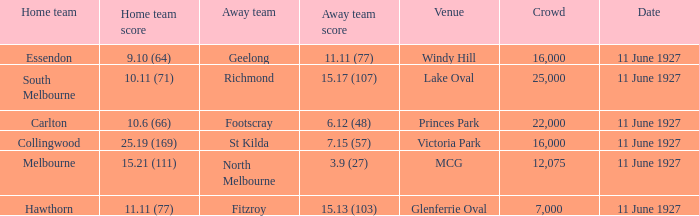How many people were present in a total of every crowd at the MCG venue? 12075.0. 